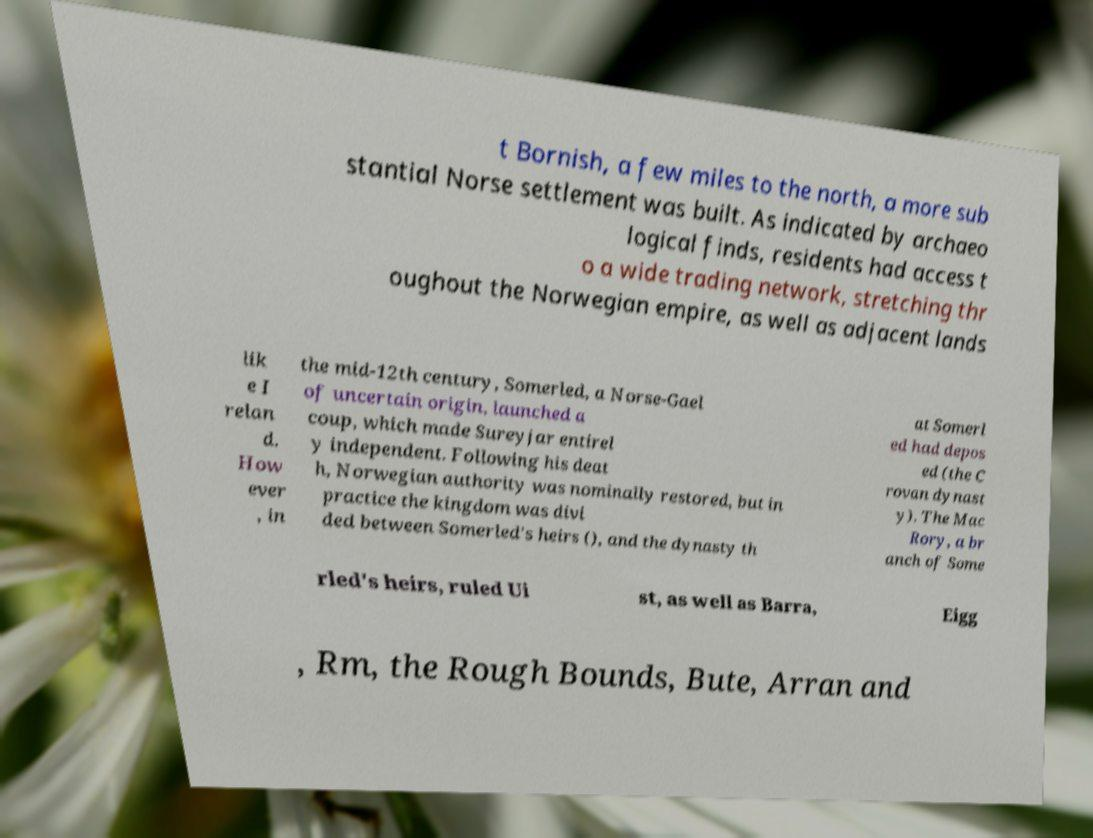For documentation purposes, I need the text within this image transcribed. Could you provide that? t Bornish, a few miles to the north, a more sub stantial Norse settlement was built. As indicated by archaeo logical finds, residents had access t o a wide trading network, stretching thr oughout the Norwegian empire, as well as adjacent lands lik e I relan d. How ever , in the mid-12th century, Somerled, a Norse-Gael of uncertain origin, launched a coup, which made Sureyjar entirel y independent. Following his deat h, Norwegian authority was nominally restored, but in practice the kingdom was divi ded between Somerled's heirs (), and the dynasty th at Somerl ed had depos ed (the C rovan dynast y). The Mac Rory, a br anch of Some rled's heirs, ruled Ui st, as well as Barra, Eigg , Rm, the Rough Bounds, Bute, Arran and 